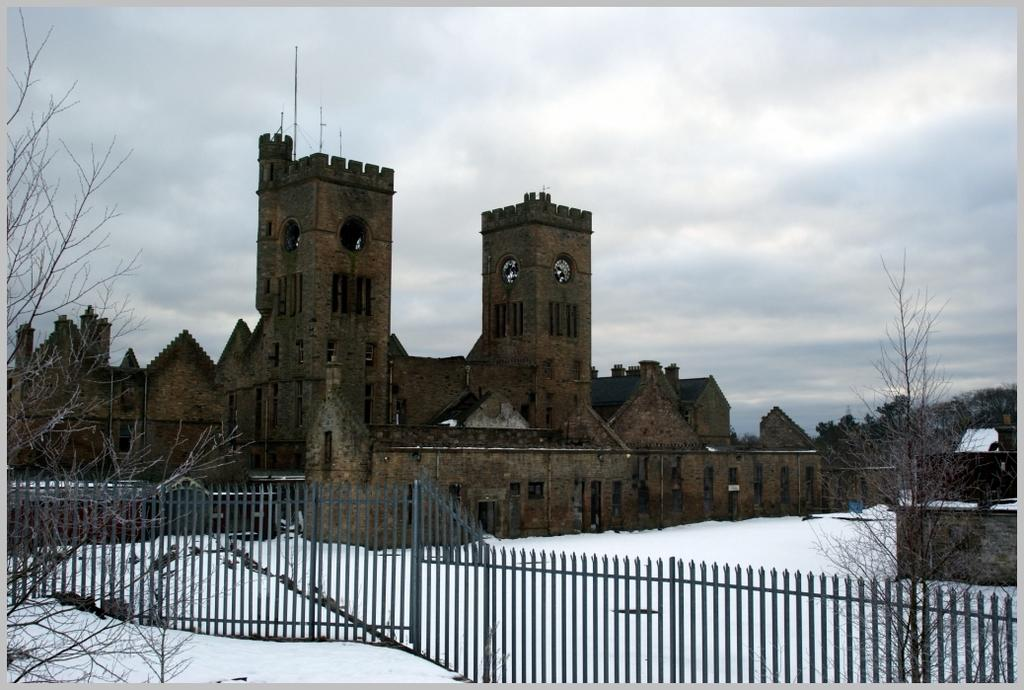What type of structure is present in the image? There is a building in the image. How is the ground depicted in the image? The ground is covered in snow. What type of barrier can be seen in the image? There is a fence in the image. What type of vegetation is present in the image? There are bare trees in the image. What can be seen in the background of the image? The sky is visible in the background of the image. What grade of gasoline is recommended for the car in the image? There is no car present in the image, so it is not possible to recommend a grade of gasoline. 